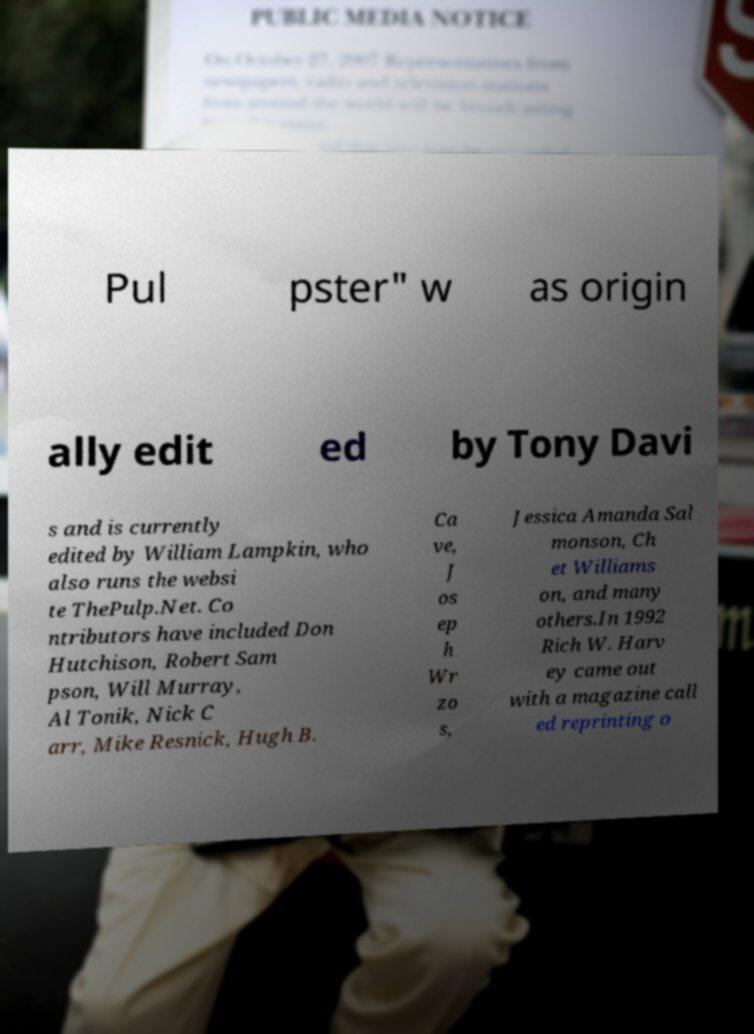There's text embedded in this image that I need extracted. Can you transcribe it verbatim? Pul pster" w as origin ally edit ed by Tony Davi s and is currently edited by William Lampkin, who also runs the websi te ThePulp.Net. Co ntributors have included Don Hutchison, Robert Sam pson, Will Murray, Al Tonik, Nick C arr, Mike Resnick, Hugh B. Ca ve, J os ep h Wr zo s, Jessica Amanda Sal monson, Ch et Williams on, and many others.In 1992 Rich W. Harv ey came out with a magazine call ed reprinting o 